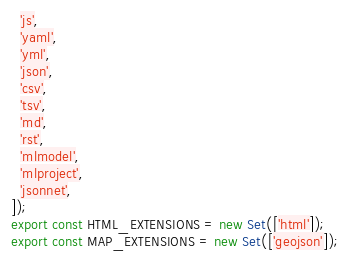<code> <loc_0><loc_0><loc_500><loc_500><_JavaScript_>  'js',
  'yaml',
  'yml',
  'json',
  'csv',
  'tsv',
  'md',
  'rst',
  'mlmodel',
  'mlproject',
  'jsonnet',
]);
export const HTML_EXTENSIONS = new Set(['html']);
export const MAP_EXTENSIONS = new Set(['geojson']);
</code> 